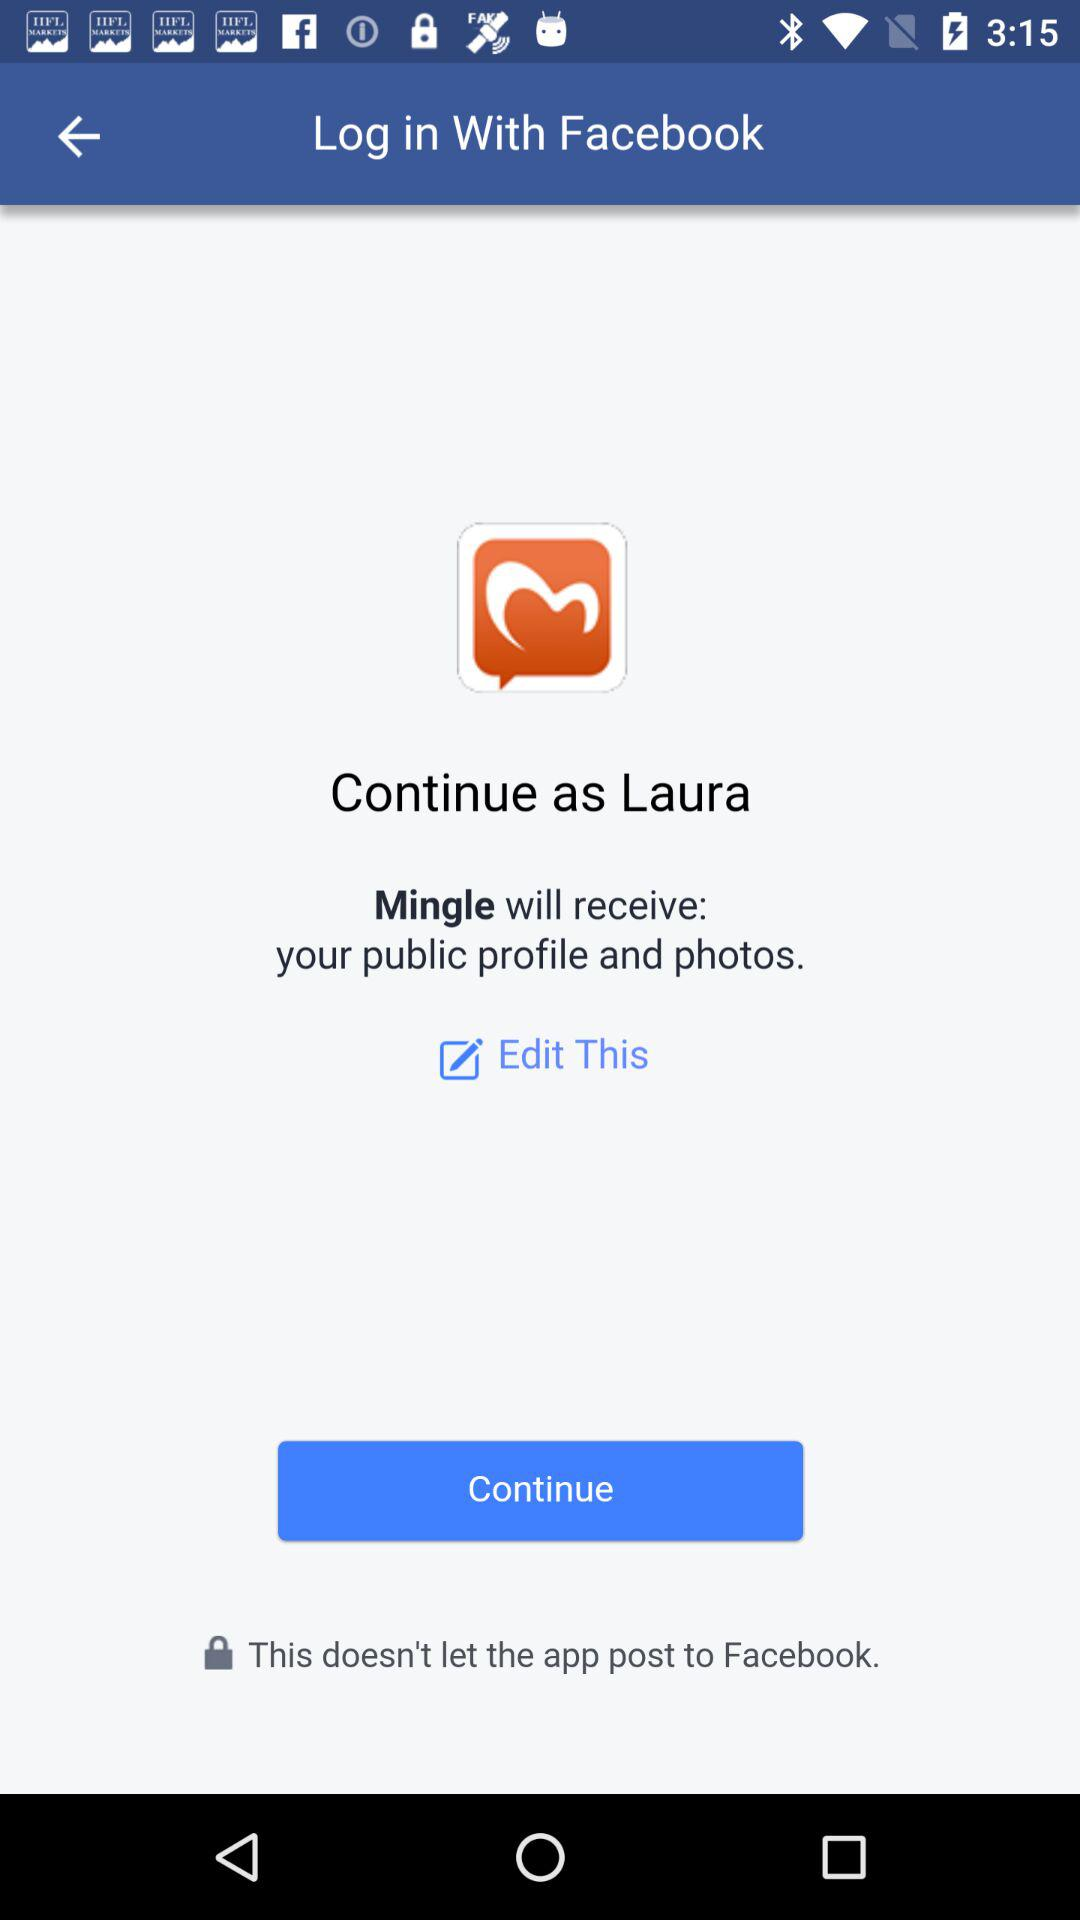What is the user name? The user name is Laura. 